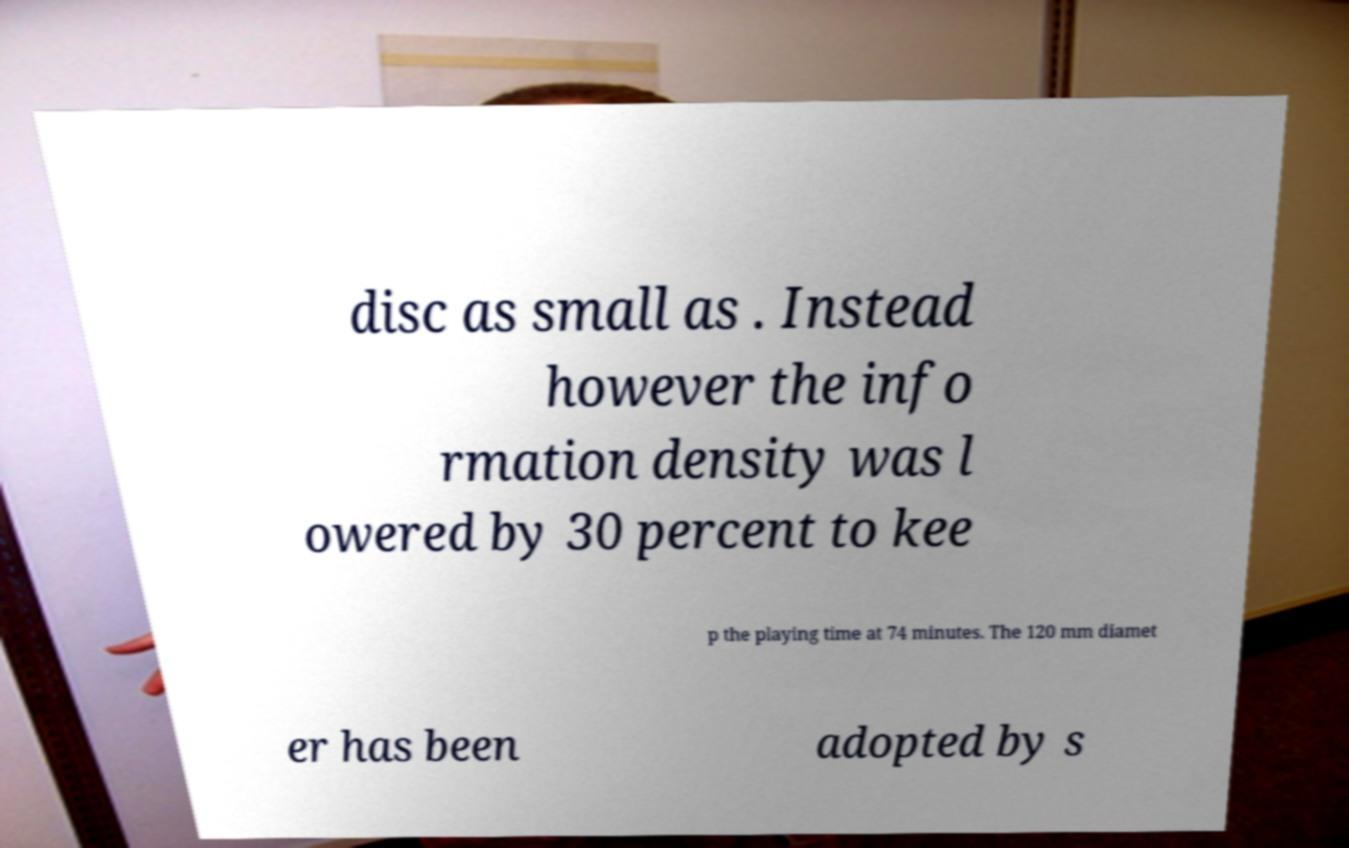Could you extract and type out the text from this image? disc as small as . Instead however the info rmation density was l owered by 30 percent to kee p the playing time at 74 minutes. The 120 mm diamet er has been adopted by s 